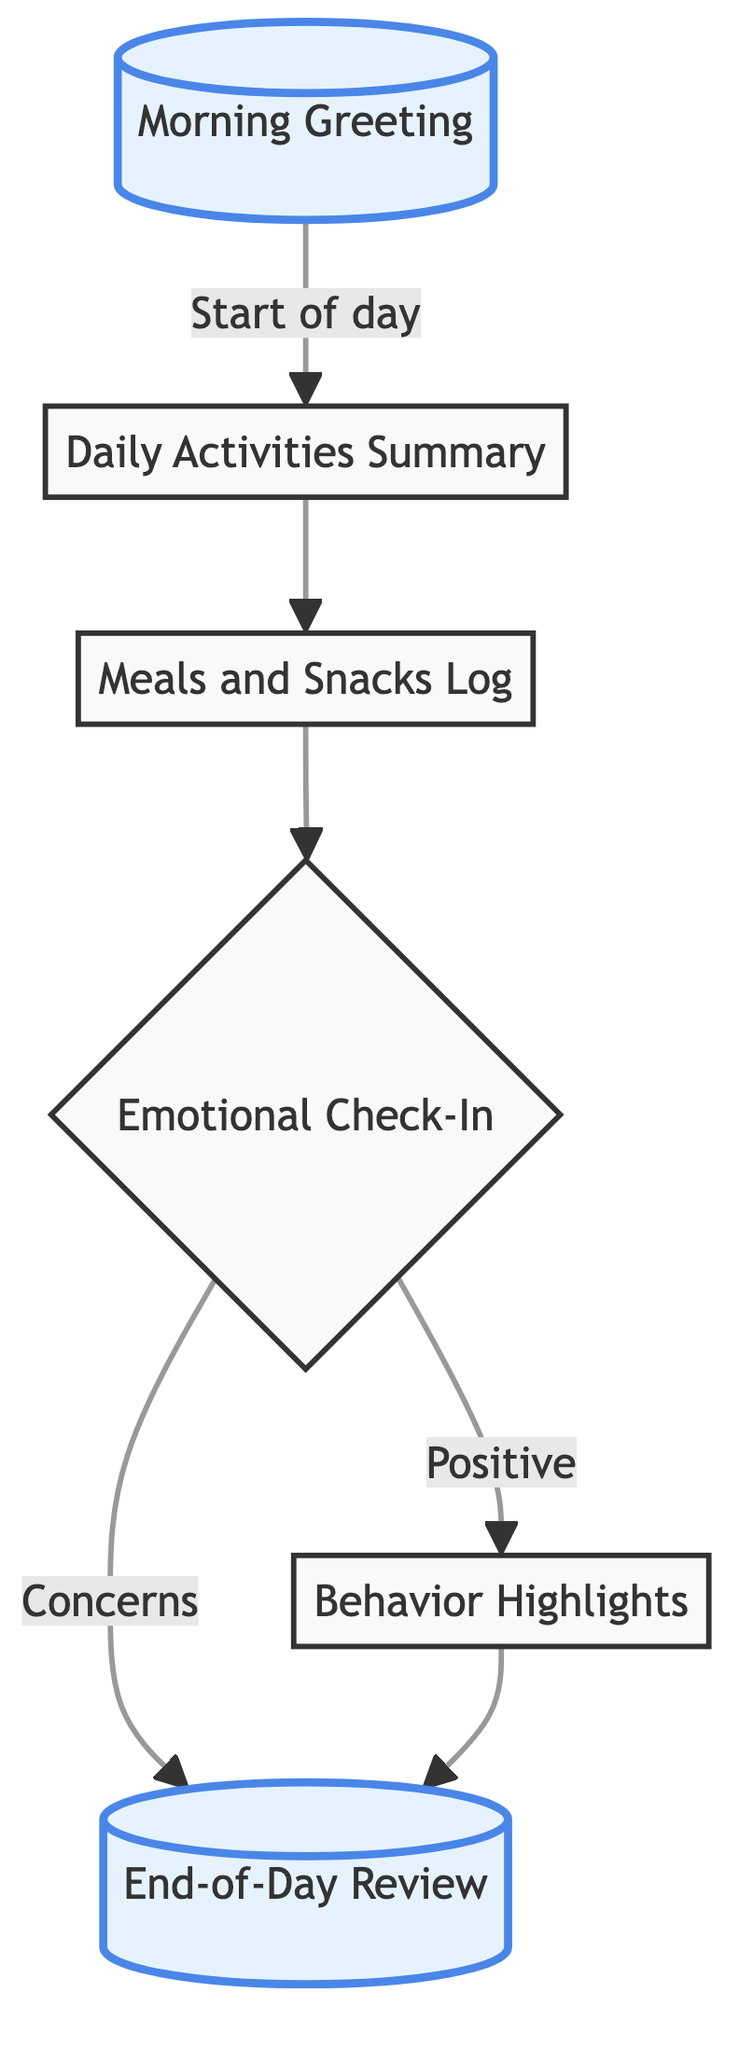What is the first step in the communication flow? The first step in the communication flow is represented by the "Morning Greeting" node, which initiates the process by greeting the child upon their arrival.
Answer: Morning Greeting How many nodes are there in total? The diagram contains six nodes, each representing a different aspect of the child's day and the communication flow with parents.
Answer: 6 What follows after the "Daily Activities Summary"? The "Meals and Snacks Log" immediately follows the "Daily Activities Summary" as the next step in the process.
Answer: Meals and Snacks Log What is discussed during the "Emotional Check-In"? During the "Emotional Check-In," the feelings of the child regarding their day and any notable moments are discussed, leading to either a positive outcome or concerns.
Answer: Feelings Which node represents a positive outcome from the emotional check-in? The "Behavior Highlights" node represents a positive outcome that follows from the "Emotional Check-In" if the child had a good day and notable achievements.
Answer: Behavior Highlights How are concerns addressed in the flow? Concerns raised during the "Emotional Check-In" lead to the "End-of-Day Review," which wraps up and allows for communication regarding any issues or worries.
Answer: End-of-Day Review Which nodes are highlighted in the diagram? The highlighted nodes in the diagram are "Morning Greeting" and "End-of-Day Review," indicating their importance in the flow of communication.
Answer: Morning Greeting, End-of-Day Review What is the last step in the communication flow? The last step in the communication flow is the "End-of-Day Review," where communication concludes with the parent through a text or call.
Answer: End-of-Day Review What type of information is logged in the "Meals and Snacks Log"? The "Meals and Snacks Log" records the information on what the child ate throughout the day.
Answer: Food eaten 